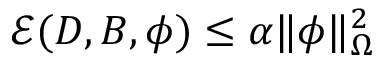<formula> <loc_0><loc_0><loc_500><loc_500>\mathcal { E } ( D , B , \phi ) \leq \alpha \| \phi \| _ { \Omega } ^ { 2 }</formula> 